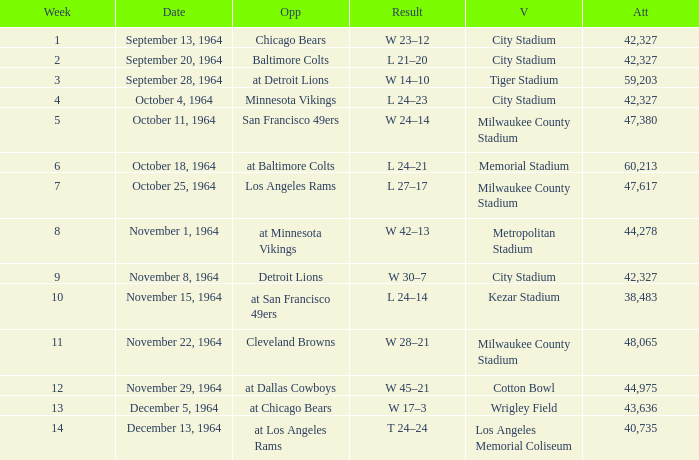What is the average attendance at a week 4 game? 42327.0. 